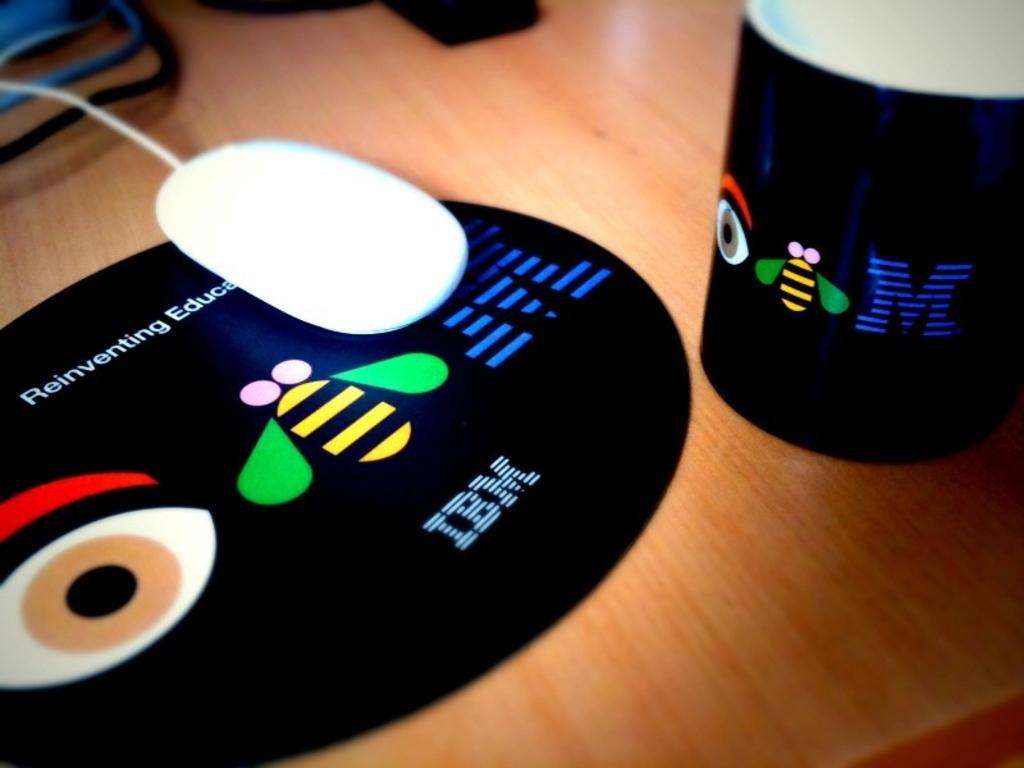Provide a one-sentence caption for the provided image. An IBM mousepad and mug sitting on a wooden table. 